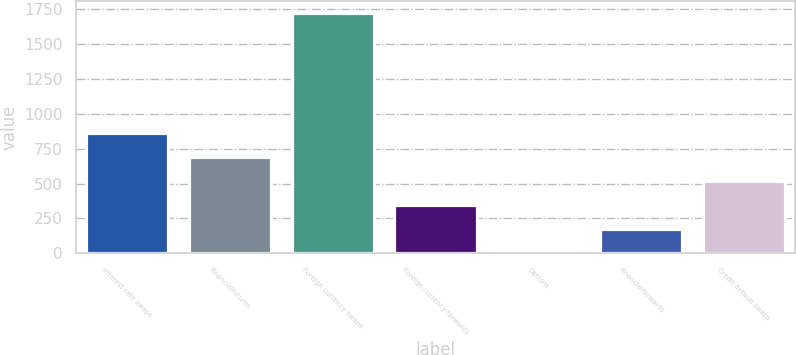<chart> <loc_0><loc_0><loc_500><loc_500><bar_chart><fcel>Interest rate swaps<fcel>Financialfutures<fcel>Foreign currency swaps<fcel>Foreign currency forwards<fcel>Options<fcel>Financialforwards<fcel>Credit default swaps<nl><fcel>860<fcel>688.2<fcel>1719<fcel>344.6<fcel>1<fcel>172.8<fcel>516.4<nl></chart> 